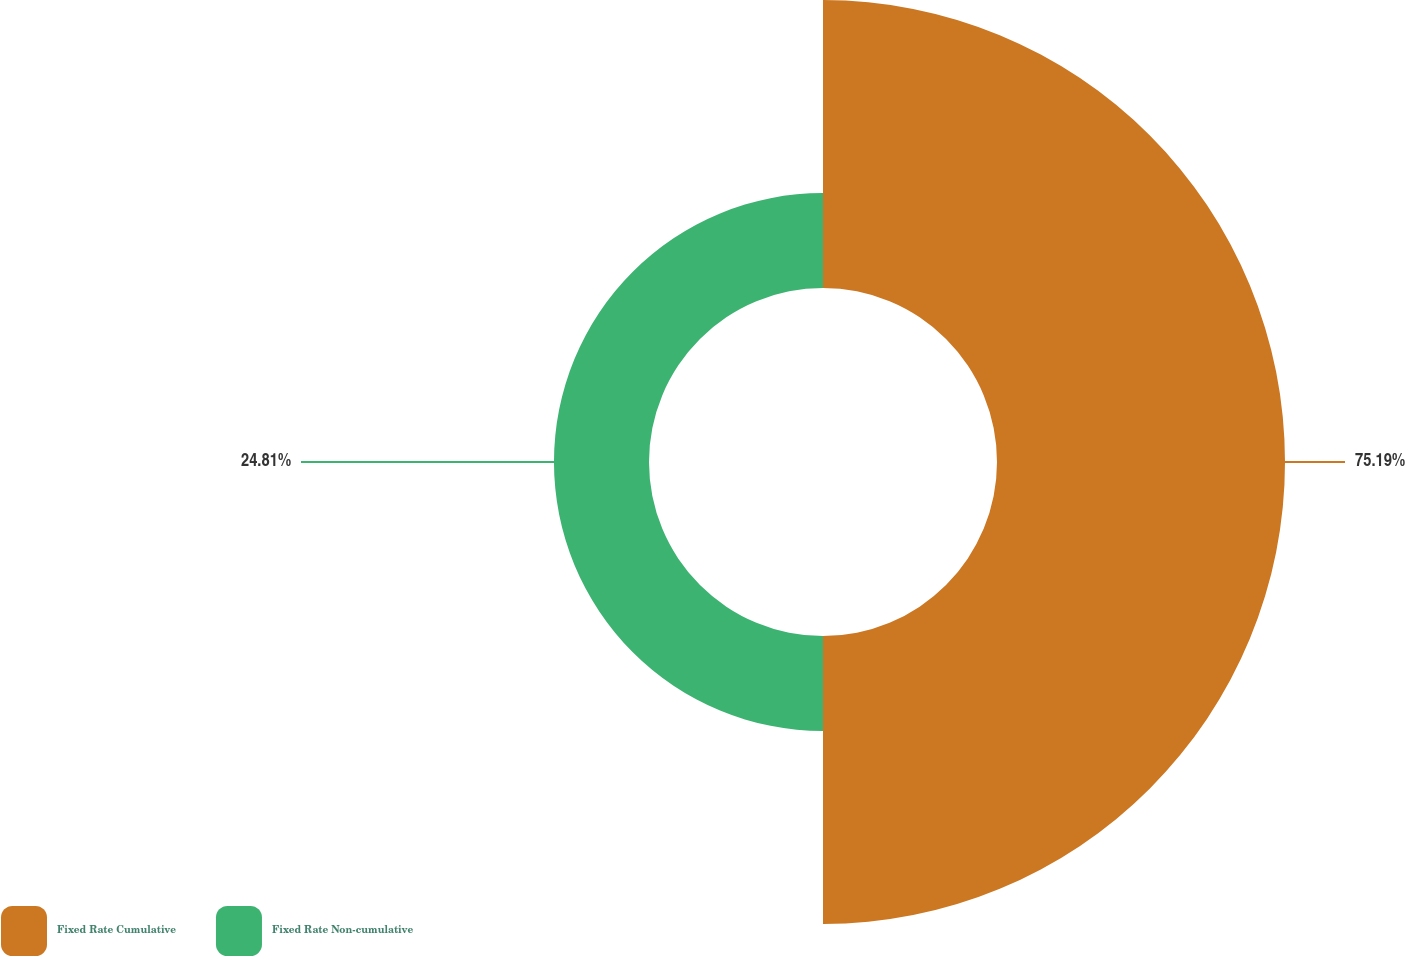Convert chart. <chart><loc_0><loc_0><loc_500><loc_500><pie_chart><fcel>Fixed Rate Cumulative<fcel>Fixed Rate Non-cumulative<nl><fcel>75.19%<fcel>24.81%<nl></chart> 